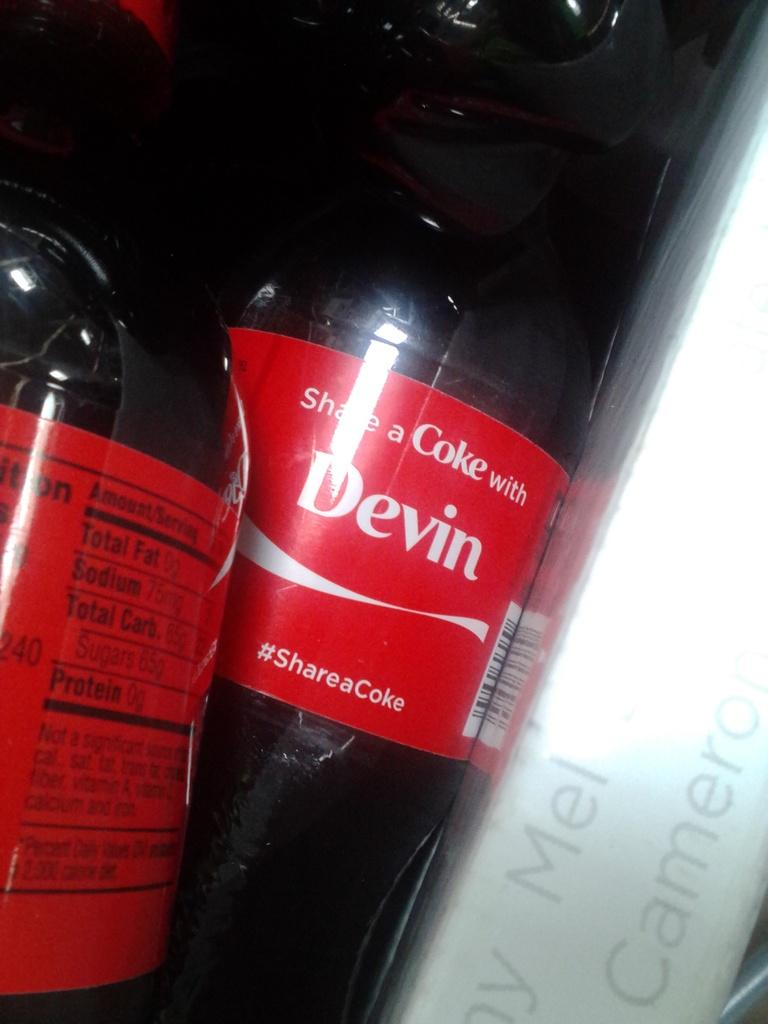<image>
Present a compact description of the photo's key features. the word Devin is on the back of a coke bottle 